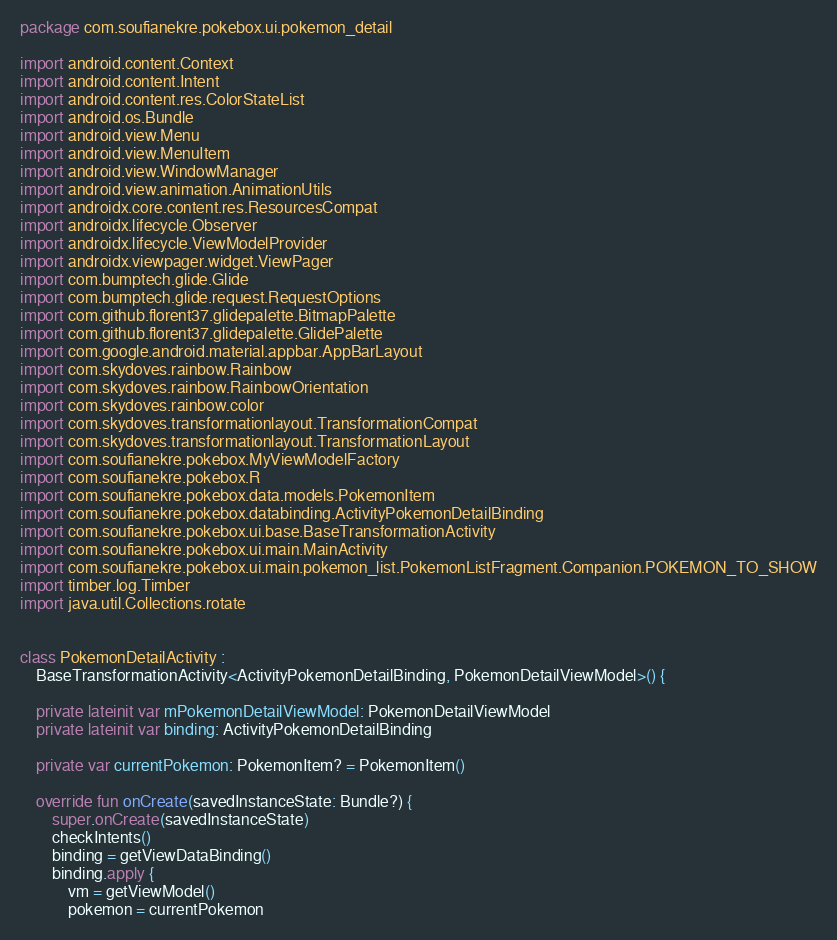<code> <loc_0><loc_0><loc_500><loc_500><_Kotlin_>package com.soufianekre.pokebox.ui.pokemon_detail

import android.content.Context
import android.content.Intent
import android.content.res.ColorStateList
import android.os.Bundle
import android.view.Menu
import android.view.MenuItem
import android.view.WindowManager
import android.view.animation.AnimationUtils
import androidx.core.content.res.ResourcesCompat
import androidx.lifecycle.Observer
import androidx.lifecycle.ViewModelProvider
import androidx.viewpager.widget.ViewPager
import com.bumptech.glide.Glide
import com.bumptech.glide.request.RequestOptions
import com.github.florent37.glidepalette.BitmapPalette
import com.github.florent37.glidepalette.GlidePalette
import com.google.android.material.appbar.AppBarLayout
import com.skydoves.rainbow.Rainbow
import com.skydoves.rainbow.RainbowOrientation
import com.skydoves.rainbow.color
import com.skydoves.transformationlayout.TransformationCompat
import com.skydoves.transformationlayout.TransformationLayout
import com.soufianekre.pokebox.MyViewModelFactory
import com.soufianekre.pokebox.R
import com.soufianekre.pokebox.data.models.PokemonItem
import com.soufianekre.pokebox.databinding.ActivityPokemonDetailBinding
import com.soufianekre.pokebox.ui.base.BaseTransformationActivity
import com.soufianekre.pokebox.ui.main.MainActivity
import com.soufianekre.pokebox.ui.main.pokemon_list.PokemonListFragment.Companion.POKEMON_TO_SHOW
import timber.log.Timber
import java.util.Collections.rotate


class PokemonDetailActivity :
    BaseTransformationActivity<ActivityPokemonDetailBinding, PokemonDetailViewModel>() {

    private lateinit var mPokemonDetailViewModel: PokemonDetailViewModel
    private lateinit var binding: ActivityPokemonDetailBinding

    private var currentPokemon: PokemonItem? = PokemonItem()

    override fun onCreate(savedInstanceState: Bundle?) {
        super.onCreate(savedInstanceState)
        checkIntents()
        binding = getViewDataBinding()
        binding.apply {
            vm = getViewModel()
            pokemon = currentPokemon</code> 